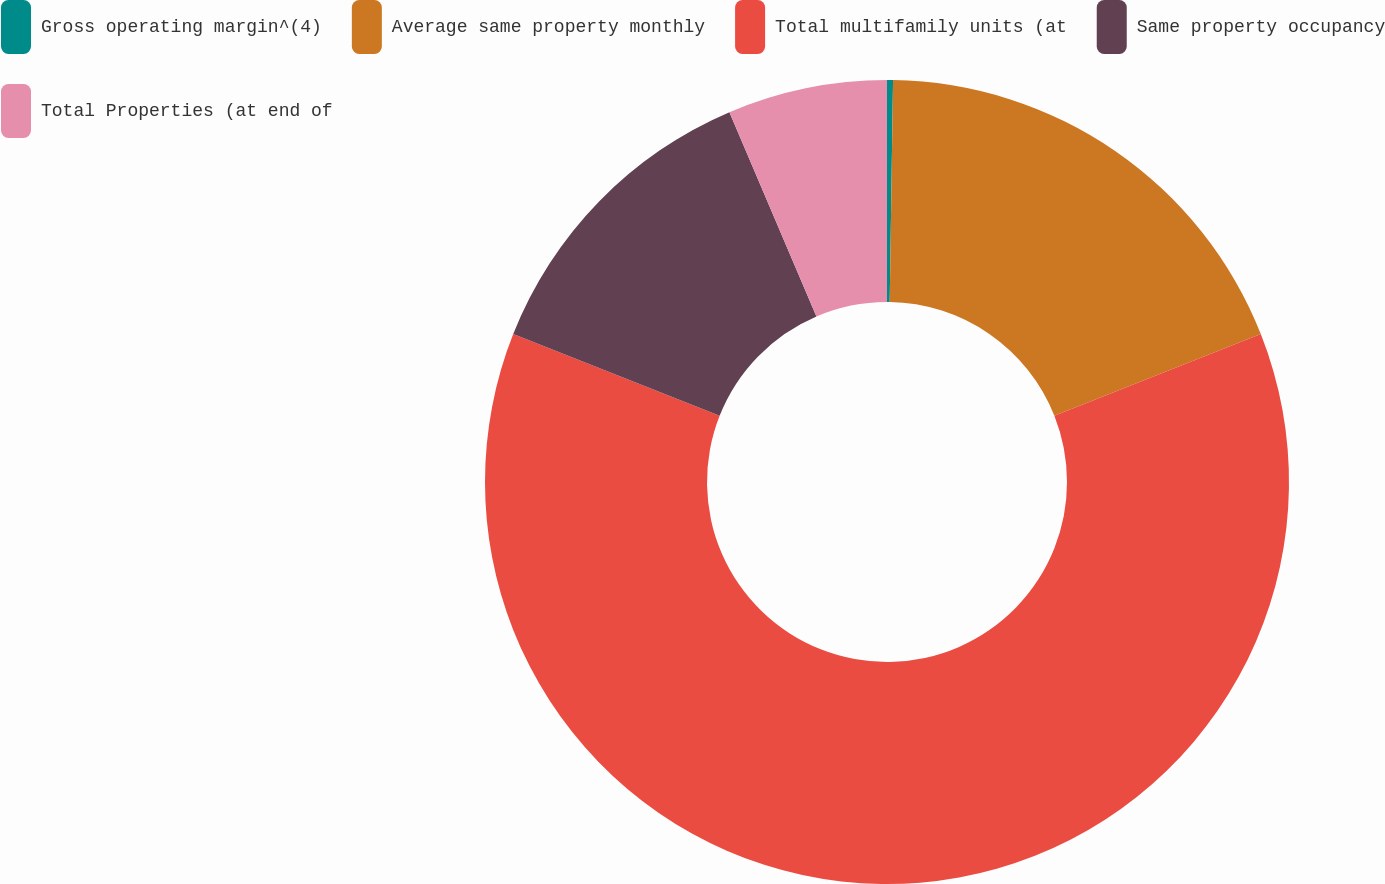<chart> <loc_0><loc_0><loc_500><loc_500><pie_chart><fcel>Gross operating margin^(4)<fcel>Average same property monthly<fcel>Total multifamily units (at<fcel>Same property occupancy<fcel>Total Properties (at end of<nl><fcel>0.24%<fcel>18.76%<fcel>61.99%<fcel>12.59%<fcel>6.41%<nl></chart> 